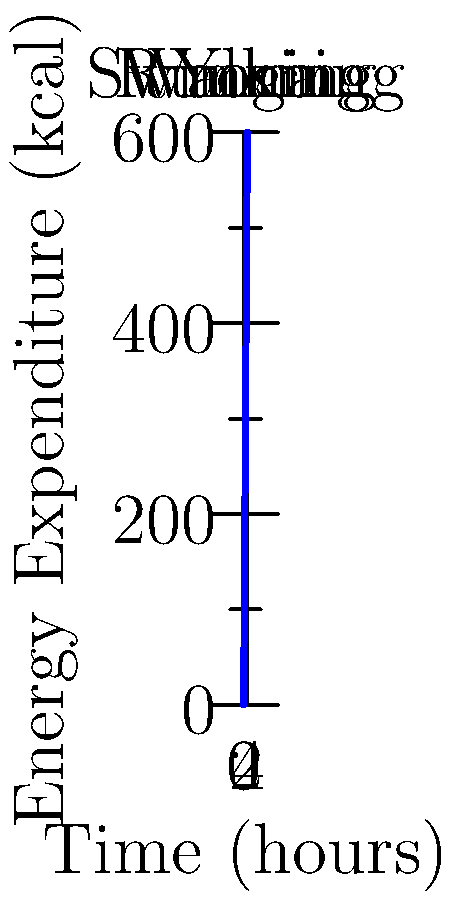As part of your holistic health improvement plan, you've been tracking your energy expenditure during various physical activities. The graph shows the cumulative energy burned over time for different exercises. If you perform each activity for 1 hour, what is the total energy expended in kilocalories (kcal)? To solve this problem, we need to:

1. Identify the energy expenditure for each activity from the graph:
   - Walking: 150 kcal/hour
   - Yoga: 150 kcal/hour (300 - 150 = 150)
   - Swimming: 150 kcal/hour (450 - 300 = 150)
   - Running: 150 kcal/hour (600 - 450 = 150)

2. Sum up the energy expenditure for all activities:
   $$\text{Total Energy} = E_{\text{walking}} + E_{\text{yoga}} + E_{\text{swimming}} + E_{\text{running}}$$
   $$\text{Total Energy} = 150 + 150 + 150 + 150 = 600 \text{ kcal}$$

Therefore, the total energy expended when performing each activity for 1 hour is 600 kcal.
Answer: 600 kcal 